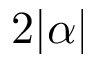<formula> <loc_0><loc_0><loc_500><loc_500>2 | \alpha |</formula> 